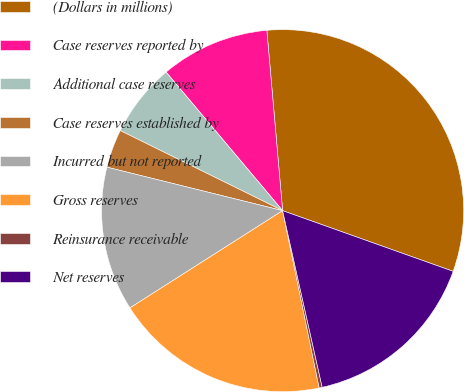Convert chart. <chart><loc_0><loc_0><loc_500><loc_500><pie_chart><fcel>(Dollars in millions)<fcel>Case reserves reported by<fcel>Additional case reserves<fcel>Case reserves established by<fcel>Incurred but not reported<fcel>Gross reserves<fcel>Reinsurance receivable<fcel>Net reserves<nl><fcel>31.83%<fcel>9.74%<fcel>6.58%<fcel>3.43%<fcel>12.89%<fcel>19.21%<fcel>0.27%<fcel>16.05%<nl></chart> 